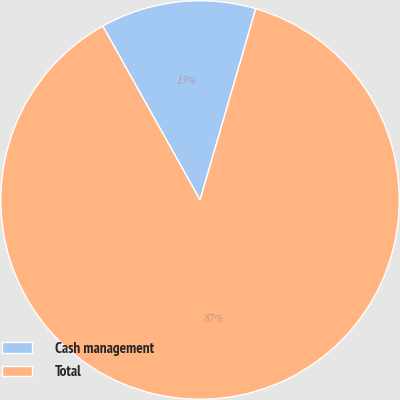Convert chart to OTSL. <chart><loc_0><loc_0><loc_500><loc_500><pie_chart><fcel>Cash management<fcel>Total<nl><fcel>12.63%<fcel>87.37%<nl></chart> 